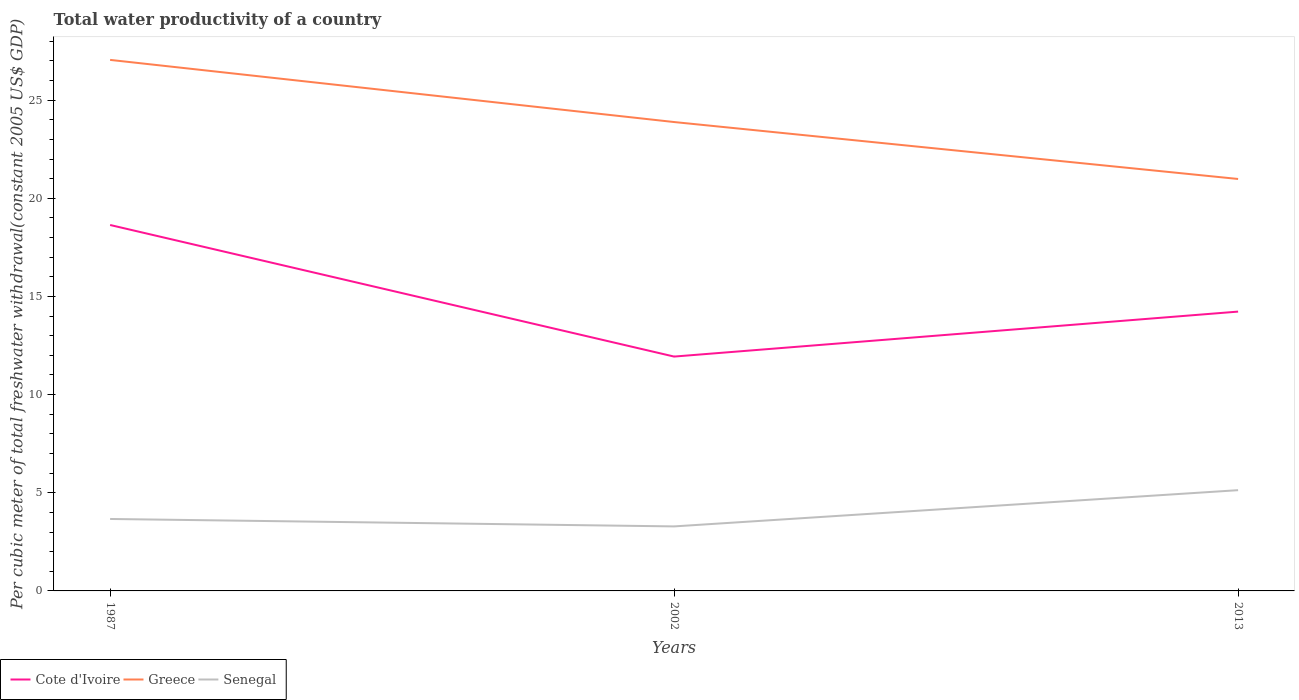How many different coloured lines are there?
Offer a very short reply. 3. Across all years, what is the maximum total water productivity in Senegal?
Your response must be concise. 3.29. What is the total total water productivity in Greece in the graph?
Keep it short and to the point. 6.07. What is the difference between the highest and the second highest total water productivity in Greece?
Provide a succinct answer. 6.07. What is the difference between the highest and the lowest total water productivity in Cote d'Ivoire?
Give a very brief answer. 1. How many years are there in the graph?
Offer a terse response. 3. What is the difference between two consecutive major ticks on the Y-axis?
Ensure brevity in your answer.  5. Are the values on the major ticks of Y-axis written in scientific E-notation?
Your answer should be very brief. No. Does the graph contain grids?
Make the answer very short. No. What is the title of the graph?
Your answer should be very brief. Total water productivity of a country. What is the label or title of the Y-axis?
Your answer should be very brief. Per cubic meter of total freshwater withdrawal(constant 2005 US$ GDP). What is the Per cubic meter of total freshwater withdrawal(constant 2005 US$ GDP) of Cote d'Ivoire in 1987?
Your answer should be very brief. 18.64. What is the Per cubic meter of total freshwater withdrawal(constant 2005 US$ GDP) of Greece in 1987?
Your answer should be compact. 27.05. What is the Per cubic meter of total freshwater withdrawal(constant 2005 US$ GDP) in Senegal in 1987?
Provide a short and direct response. 3.67. What is the Per cubic meter of total freshwater withdrawal(constant 2005 US$ GDP) of Cote d'Ivoire in 2002?
Your response must be concise. 11.94. What is the Per cubic meter of total freshwater withdrawal(constant 2005 US$ GDP) of Greece in 2002?
Your answer should be very brief. 23.88. What is the Per cubic meter of total freshwater withdrawal(constant 2005 US$ GDP) in Senegal in 2002?
Provide a succinct answer. 3.29. What is the Per cubic meter of total freshwater withdrawal(constant 2005 US$ GDP) in Cote d'Ivoire in 2013?
Keep it short and to the point. 14.23. What is the Per cubic meter of total freshwater withdrawal(constant 2005 US$ GDP) of Greece in 2013?
Your answer should be compact. 20.98. What is the Per cubic meter of total freshwater withdrawal(constant 2005 US$ GDP) in Senegal in 2013?
Ensure brevity in your answer.  5.13. Across all years, what is the maximum Per cubic meter of total freshwater withdrawal(constant 2005 US$ GDP) of Cote d'Ivoire?
Keep it short and to the point. 18.64. Across all years, what is the maximum Per cubic meter of total freshwater withdrawal(constant 2005 US$ GDP) of Greece?
Provide a short and direct response. 27.05. Across all years, what is the maximum Per cubic meter of total freshwater withdrawal(constant 2005 US$ GDP) of Senegal?
Your answer should be very brief. 5.13. Across all years, what is the minimum Per cubic meter of total freshwater withdrawal(constant 2005 US$ GDP) of Cote d'Ivoire?
Your answer should be compact. 11.94. Across all years, what is the minimum Per cubic meter of total freshwater withdrawal(constant 2005 US$ GDP) of Greece?
Your response must be concise. 20.98. Across all years, what is the minimum Per cubic meter of total freshwater withdrawal(constant 2005 US$ GDP) of Senegal?
Offer a terse response. 3.29. What is the total Per cubic meter of total freshwater withdrawal(constant 2005 US$ GDP) of Cote d'Ivoire in the graph?
Provide a succinct answer. 44.81. What is the total Per cubic meter of total freshwater withdrawal(constant 2005 US$ GDP) in Greece in the graph?
Your response must be concise. 71.92. What is the total Per cubic meter of total freshwater withdrawal(constant 2005 US$ GDP) in Senegal in the graph?
Keep it short and to the point. 12.08. What is the difference between the Per cubic meter of total freshwater withdrawal(constant 2005 US$ GDP) of Cote d'Ivoire in 1987 and that in 2002?
Your answer should be very brief. 6.7. What is the difference between the Per cubic meter of total freshwater withdrawal(constant 2005 US$ GDP) in Greece in 1987 and that in 2002?
Provide a succinct answer. 3.17. What is the difference between the Per cubic meter of total freshwater withdrawal(constant 2005 US$ GDP) of Senegal in 1987 and that in 2002?
Make the answer very short. 0.38. What is the difference between the Per cubic meter of total freshwater withdrawal(constant 2005 US$ GDP) in Cote d'Ivoire in 1987 and that in 2013?
Make the answer very short. 4.41. What is the difference between the Per cubic meter of total freshwater withdrawal(constant 2005 US$ GDP) of Greece in 1987 and that in 2013?
Make the answer very short. 6.07. What is the difference between the Per cubic meter of total freshwater withdrawal(constant 2005 US$ GDP) in Senegal in 1987 and that in 2013?
Your answer should be compact. -1.47. What is the difference between the Per cubic meter of total freshwater withdrawal(constant 2005 US$ GDP) of Cote d'Ivoire in 2002 and that in 2013?
Your answer should be very brief. -2.29. What is the difference between the Per cubic meter of total freshwater withdrawal(constant 2005 US$ GDP) in Greece in 2002 and that in 2013?
Provide a succinct answer. 2.9. What is the difference between the Per cubic meter of total freshwater withdrawal(constant 2005 US$ GDP) of Senegal in 2002 and that in 2013?
Your response must be concise. -1.85. What is the difference between the Per cubic meter of total freshwater withdrawal(constant 2005 US$ GDP) of Cote d'Ivoire in 1987 and the Per cubic meter of total freshwater withdrawal(constant 2005 US$ GDP) of Greece in 2002?
Provide a short and direct response. -5.24. What is the difference between the Per cubic meter of total freshwater withdrawal(constant 2005 US$ GDP) of Cote d'Ivoire in 1987 and the Per cubic meter of total freshwater withdrawal(constant 2005 US$ GDP) of Senegal in 2002?
Your answer should be very brief. 15.35. What is the difference between the Per cubic meter of total freshwater withdrawal(constant 2005 US$ GDP) in Greece in 1987 and the Per cubic meter of total freshwater withdrawal(constant 2005 US$ GDP) in Senegal in 2002?
Ensure brevity in your answer.  23.76. What is the difference between the Per cubic meter of total freshwater withdrawal(constant 2005 US$ GDP) of Cote d'Ivoire in 1987 and the Per cubic meter of total freshwater withdrawal(constant 2005 US$ GDP) of Greece in 2013?
Ensure brevity in your answer.  -2.34. What is the difference between the Per cubic meter of total freshwater withdrawal(constant 2005 US$ GDP) of Cote d'Ivoire in 1987 and the Per cubic meter of total freshwater withdrawal(constant 2005 US$ GDP) of Senegal in 2013?
Make the answer very short. 13.51. What is the difference between the Per cubic meter of total freshwater withdrawal(constant 2005 US$ GDP) of Greece in 1987 and the Per cubic meter of total freshwater withdrawal(constant 2005 US$ GDP) of Senegal in 2013?
Offer a very short reply. 21.92. What is the difference between the Per cubic meter of total freshwater withdrawal(constant 2005 US$ GDP) in Cote d'Ivoire in 2002 and the Per cubic meter of total freshwater withdrawal(constant 2005 US$ GDP) in Greece in 2013?
Give a very brief answer. -9.05. What is the difference between the Per cubic meter of total freshwater withdrawal(constant 2005 US$ GDP) in Cote d'Ivoire in 2002 and the Per cubic meter of total freshwater withdrawal(constant 2005 US$ GDP) in Senegal in 2013?
Offer a terse response. 6.81. What is the difference between the Per cubic meter of total freshwater withdrawal(constant 2005 US$ GDP) of Greece in 2002 and the Per cubic meter of total freshwater withdrawal(constant 2005 US$ GDP) of Senegal in 2013?
Your response must be concise. 18.75. What is the average Per cubic meter of total freshwater withdrawal(constant 2005 US$ GDP) of Cote d'Ivoire per year?
Give a very brief answer. 14.94. What is the average Per cubic meter of total freshwater withdrawal(constant 2005 US$ GDP) of Greece per year?
Provide a succinct answer. 23.97. What is the average Per cubic meter of total freshwater withdrawal(constant 2005 US$ GDP) in Senegal per year?
Ensure brevity in your answer.  4.03. In the year 1987, what is the difference between the Per cubic meter of total freshwater withdrawal(constant 2005 US$ GDP) of Cote d'Ivoire and Per cubic meter of total freshwater withdrawal(constant 2005 US$ GDP) of Greece?
Provide a succinct answer. -8.41. In the year 1987, what is the difference between the Per cubic meter of total freshwater withdrawal(constant 2005 US$ GDP) of Cote d'Ivoire and Per cubic meter of total freshwater withdrawal(constant 2005 US$ GDP) of Senegal?
Provide a succinct answer. 14.97. In the year 1987, what is the difference between the Per cubic meter of total freshwater withdrawal(constant 2005 US$ GDP) in Greece and Per cubic meter of total freshwater withdrawal(constant 2005 US$ GDP) in Senegal?
Offer a very short reply. 23.38. In the year 2002, what is the difference between the Per cubic meter of total freshwater withdrawal(constant 2005 US$ GDP) of Cote d'Ivoire and Per cubic meter of total freshwater withdrawal(constant 2005 US$ GDP) of Greece?
Provide a succinct answer. -11.95. In the year 2002, what is the difference between the Per cubic meter of total freshwater withdrawal(constant 2005 US$ GDP) of Cote d'Ivoire and Per cubic meter of total freshwater withdrawal(constant 2005 US$ GDP) of Senegal?
Provide a short and direct response. 8.65. In the year 2002, what is the difference between the Per cubic meter of total freshwater withdrawal(constant 2005 US$ GDP) of Greece and Per cubic meter of total freshwater withdrawal(constant 2005 US$ GDP) of Senegal?
Offer a very short reply. 20.6. In the year 2013, what is the difference between the Per cubic meter of total freshwater withdrawal(constant 2005 US$ GDP) in Cote d'Ivoire and Per cubic meter of total freshwater withdrawal(constant 2005 US$ GDP) in Greece?
Offer a very short reply. -6.76. In the year 2013, what is the difference between the Per cubic meter of total freshwater withdrawal(constant 2005 US$ GDP) in Cote d'Ivoire and Per cubic meter of total freshwater withdrawal(constant 2005 US$ GDP) in Senegal?
Make the answer very short. 9.1. In the year 2013, what is the difference between the Per cubic meter of total freshwater withdrawal(constant 2005 US$ GDP) in Greece and Per cubic meter of total freshwater withdrawal(constant 2005 US$ GDP) in Senegal?
Provide a short and direct response. 15.85. What is the ratio of the Per cubic meter of total freshwater withdrawal(constant 2005 US$ GDP) in Cote d'Ivoire in 1987 to that in 2002?
Provide a succinct answer. 1.56. What is the ratio of the Per cubic meter of total freshwater withdrawal(constant 2005 US$ GDP) in Greece in 1987 to that in 2002?
Ensure brevity in your answer.  1.13. What is the ratio of the Per cubic meter of total freshwater withdrawal(constant 2005 US$ GDP) in Senegal in 1987 to that in 2002?
Provide a succinct answer. 1.12. What is the ratio of the Per cubic meter of total freshwater withdrawal(constant 2005 US$ GDP) of Cote d'Ivoire in 1987 to that in 2013?
Your answer should be compact. 1.31. What is the ratio of the Per cubic meter of total freshwater withdrawal(constant 2005 US$ GDP) of Greece in 1987 to that in 2013?
Make the answer very short. 1.29. What is the ratio of the Per cubic meter of total freshwater withdrawal(constant 2005 US$ GDP) in Cote d'Ivoire in 2002 to that in 2013?
Your response must be concise. 0.84. What is the ratio of the Per cubic meter of total freshwater withdrawal(constant 2005 US$ GDP) of Greece in 2002 to that in 2013?
Provide a succinct answer. 1.14. What is the ratio of the Per cubic meter of total freshwater withdrawal(constant 2005 US$ GDP) of Senegal in 2002 to that in 2013?
Offer a terse response. 0.64. What is the difference between the highest and the second highest Per cubic meter of total freshwater withdrawal(constant 2005 US$ GDP) in Cote d'Ivoire?
Keep it short and to the point. 4.41. What is the difference between the highest and the second highest Per cubic meter of total freshwater withdrawal(constant 2005 US$ GDP) of Greece?
Offer a terse response. 3.17. What is the difference between the highest and the second highest Per cubic meter of total freshwater withdrawal(constant 2005 US$ GDP) in Senegal?
Offer a terse response. 1.47. What is the difference between the highest and the lowest Per cubic meter of total freshwater withdrawal(constant 2005 US$ GDP) of Cote d'Ivoire?
Your answer should be very brief. 6.7. What is the difference between the highest and the lowest Per cubic meter of total freshwater withdrawal(constant 2005 US$ GDP) in Greece?
Make the answer very short. 6.07. What is the difference between the highest and the lowest Per cubic meter of total freshwater withdrawal(constant 2005 US$ GDP) in Senegal?
Offer a very short reply. 1.85. 